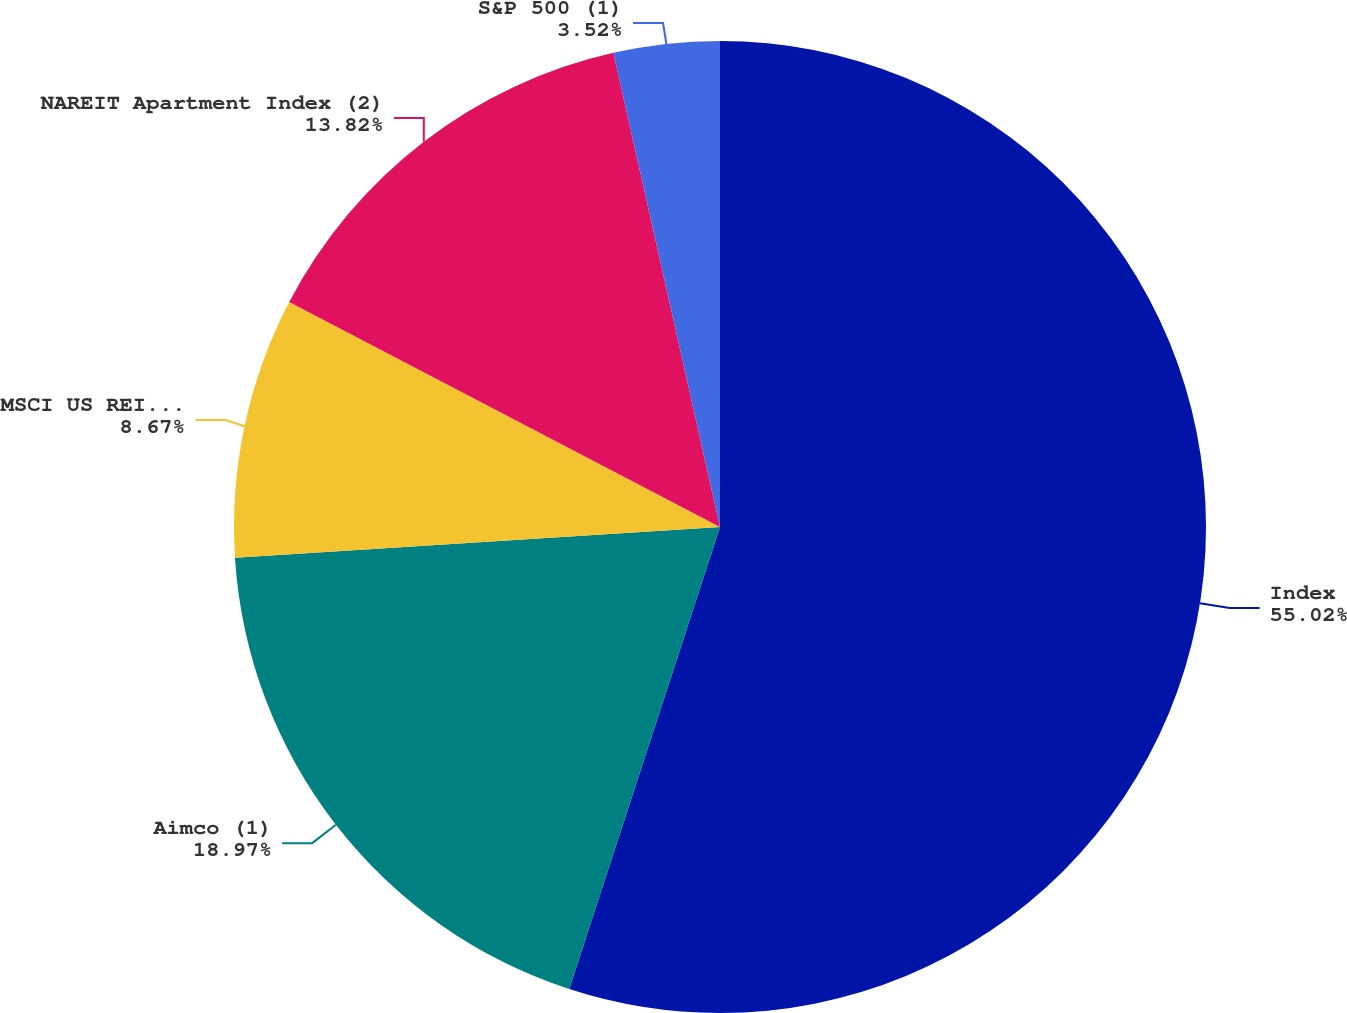Convert chart. <chart><loc_0><loc_0><loc_500><loc_500><pie_chart><fcel>Index<fcel>Aimco (1)<fcel>MSCI US REIT (1)<fcel>NAREIT Apartment Index (2)<fcel>S&P 500 (1)<nl><fcel>55.02%<fcel>18.97%<fcel>8.67%<fcel>13.82%<fcel>3.52%<nl></chart> 